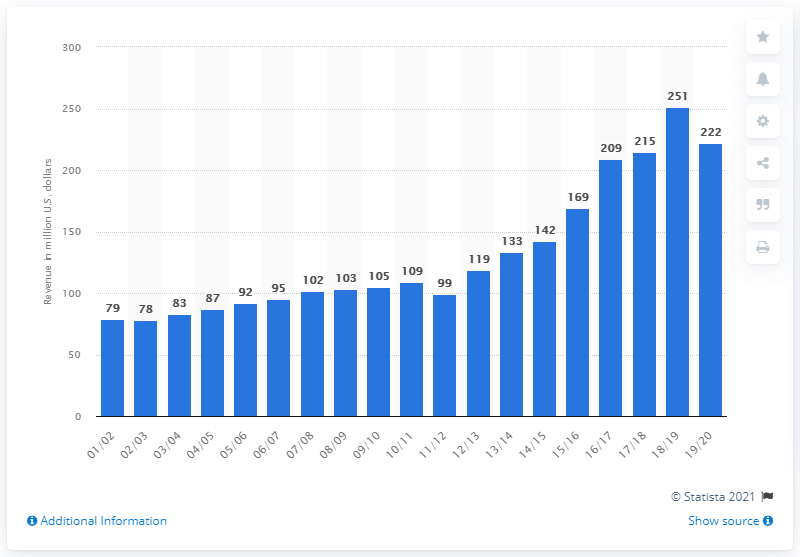Point out several critical features in this image. The estimated revenue of the Atlanta Hawks for the 2019/2020 season is approximately 222 million dollars. 